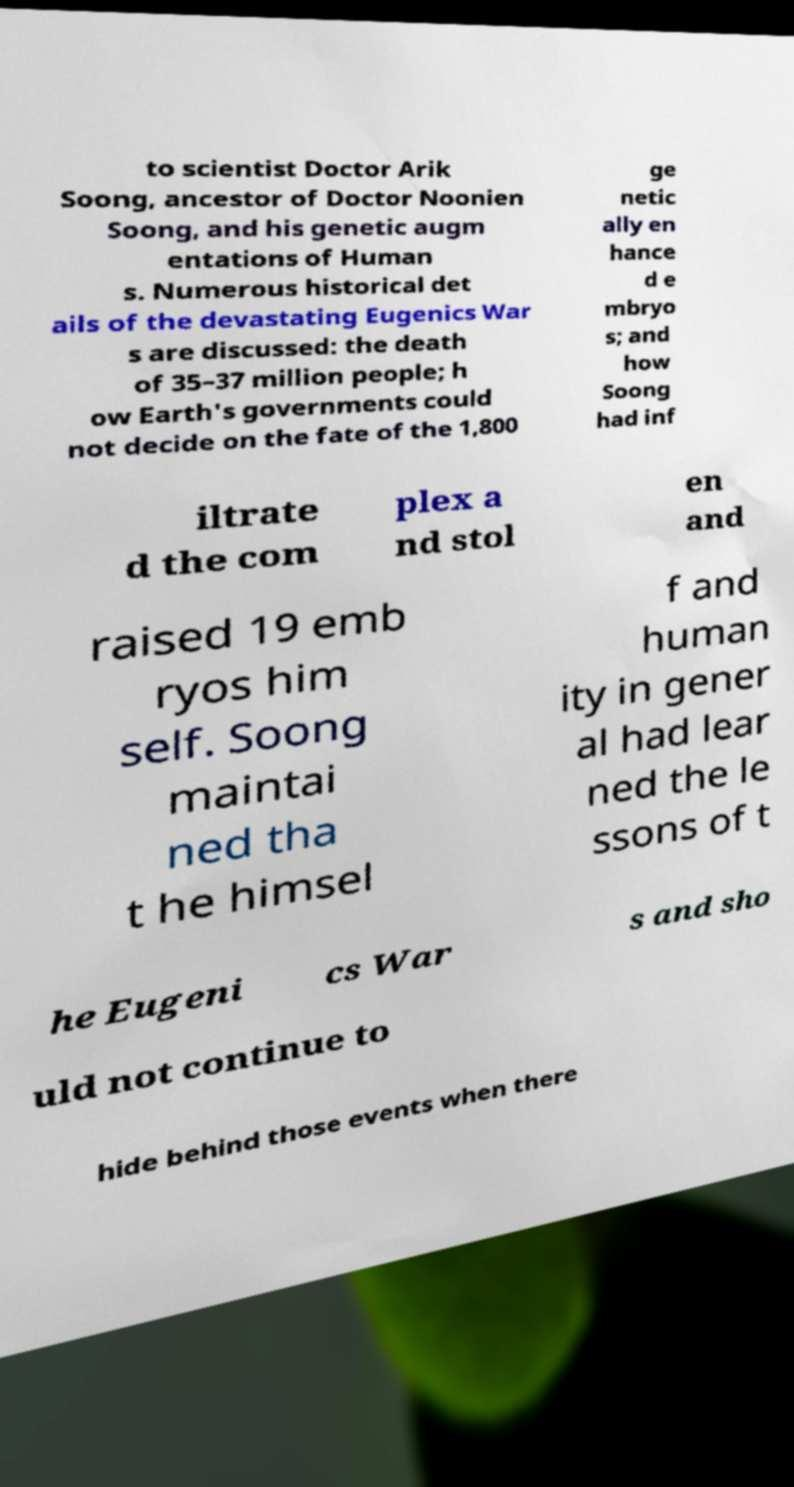There's text embedded in this image that I need extracted. Can you transcribe it verbatim? to scientist Doctor Arik Soong, ancestor of Doctor Noonien Soong, and his genetic augm entations of Human s. Numerous historical det ails of the devastating Eugenics War s are discussed: the death of 35–37 million people; h ow Earth's governments could not decide on the fate of the 1,800 ge netic ally en hance d e mbryo s; and how Soong had inf iltrate d the com plex a nd stol en and raised 19 emb ryos him self. Soong maintai ned tha t he himsel f and human ity in gener al had lear ned the le ssons of t he Eugeni cs War s and sho uld not continue to hide behind those events when there 